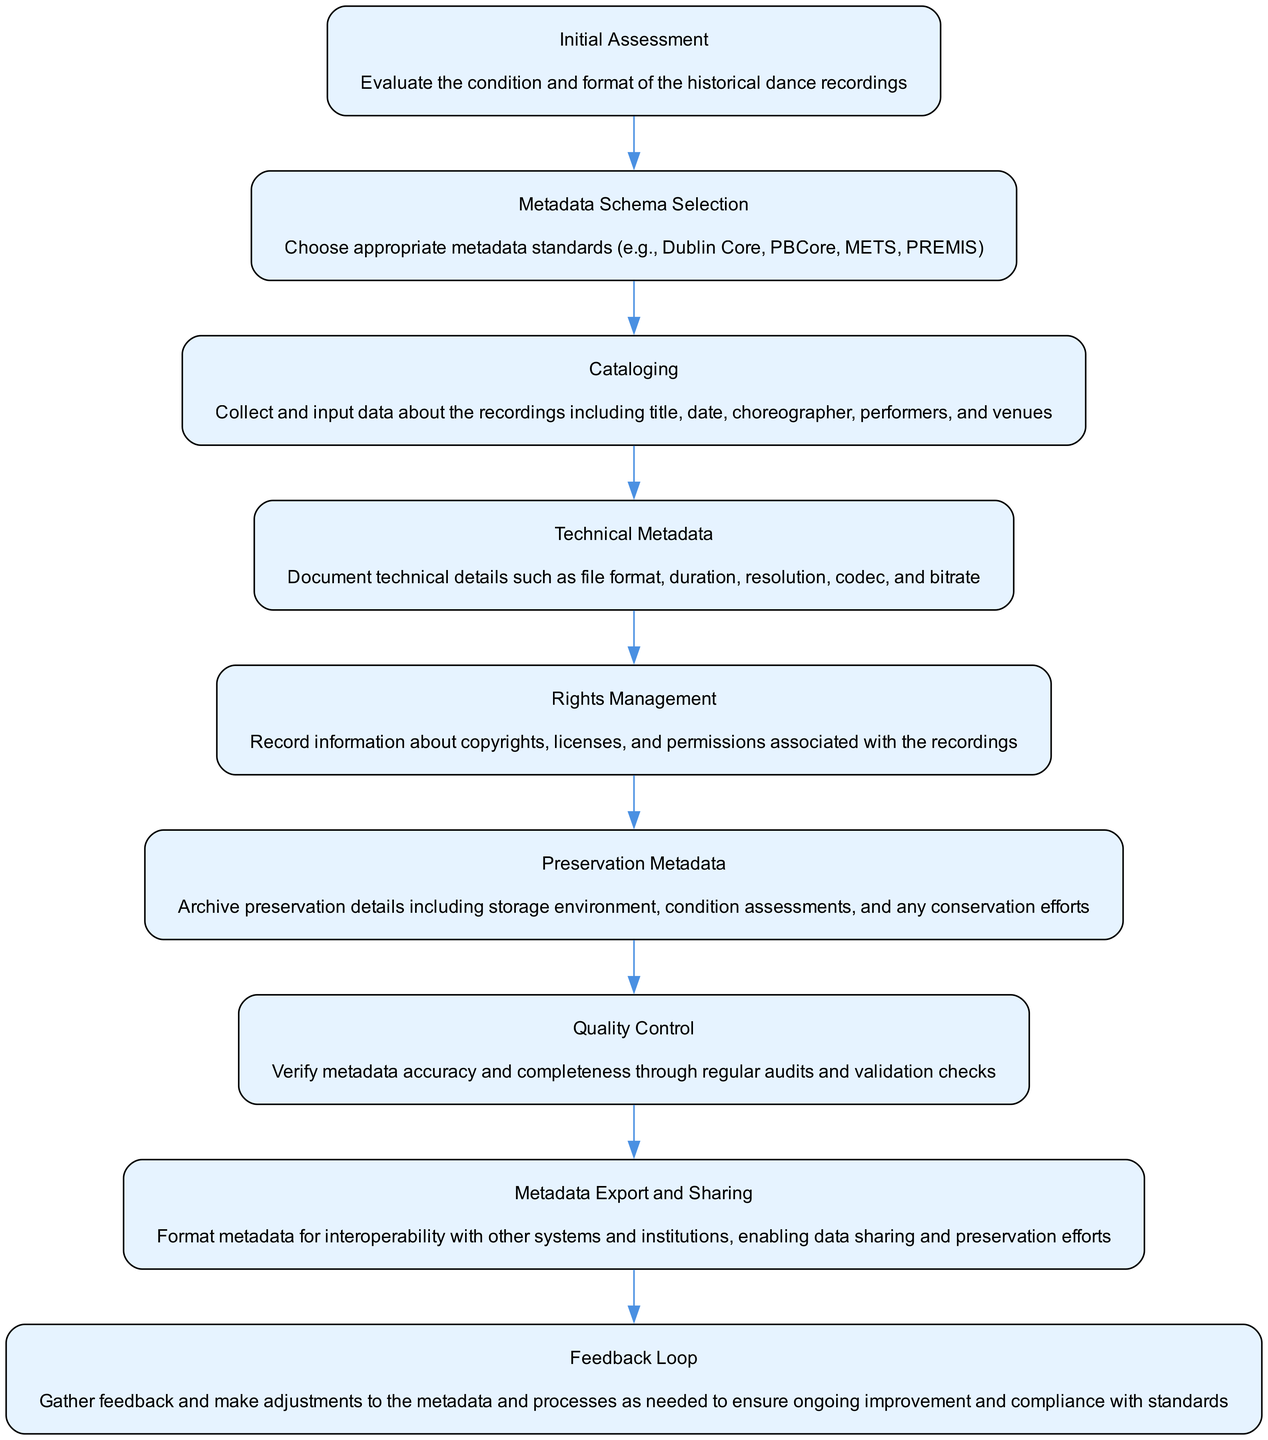What is the first step in the workflow? The first step in the diagram is "Initial Assessment", which involves evaluating the condition and format of the historical dance recordings.
Answer: Initial Assessment Which step comes after Technical Metadata? After Technical Metadata, the next step is "Rights Management". This is indicated by the directed flow from one step to another in the diagram.
Answer: Rights Management How many total nodes are present in the diagram? The diagram contains 9 nodes, which are all the steps listed in the workflow. This can be counted directly from the flowchart.
Answer: 9 What does the "Quality Control" step involve? The "Quality Control" step involves verifying metadata accuracy and completeness through regular audits and validation checks. This is detailed in the description provided for that node.
Answer: Verify metadata accuracy and completeness Which two nodes are connected directly before the feedback loop? The nodes "Metadata Export and Sharing" and "Feedback Loop" are directly connected, indicating the transition from sharing the metadata to gathering feedback for improvements.
Answer: Metadata Export and Sharing, Feedback Loop Explain the relationship between "Cataloging" and "Technical Metadata". "Cataloging" comes before "Technical Metadata" in the workflow. After collecting and inputting data about the recordings in the Cataloging step, the focus then shifts to documenting technical details in the Technical Metadata step.
Answer: "Cataloging" precedes "Technical Metadata" How is the process adjusted after gathering feedback? After gathering feedback in the "Feedback Loop", adjustments are made to the metadata and processes to ensure ongoing improvement and compliance with standards. This continuous loop indicates a commitment to dynamic enhancement based on user input.
Answer: Adjustments What type of metadata is recorded in the "Rights Management" step? The "Rights Management" step focuses on recording information about copyrights, licenses, and permissions associated with the recordings. This is specified in the description of that step.
Answer: Copyrights, licenses, and permissions 